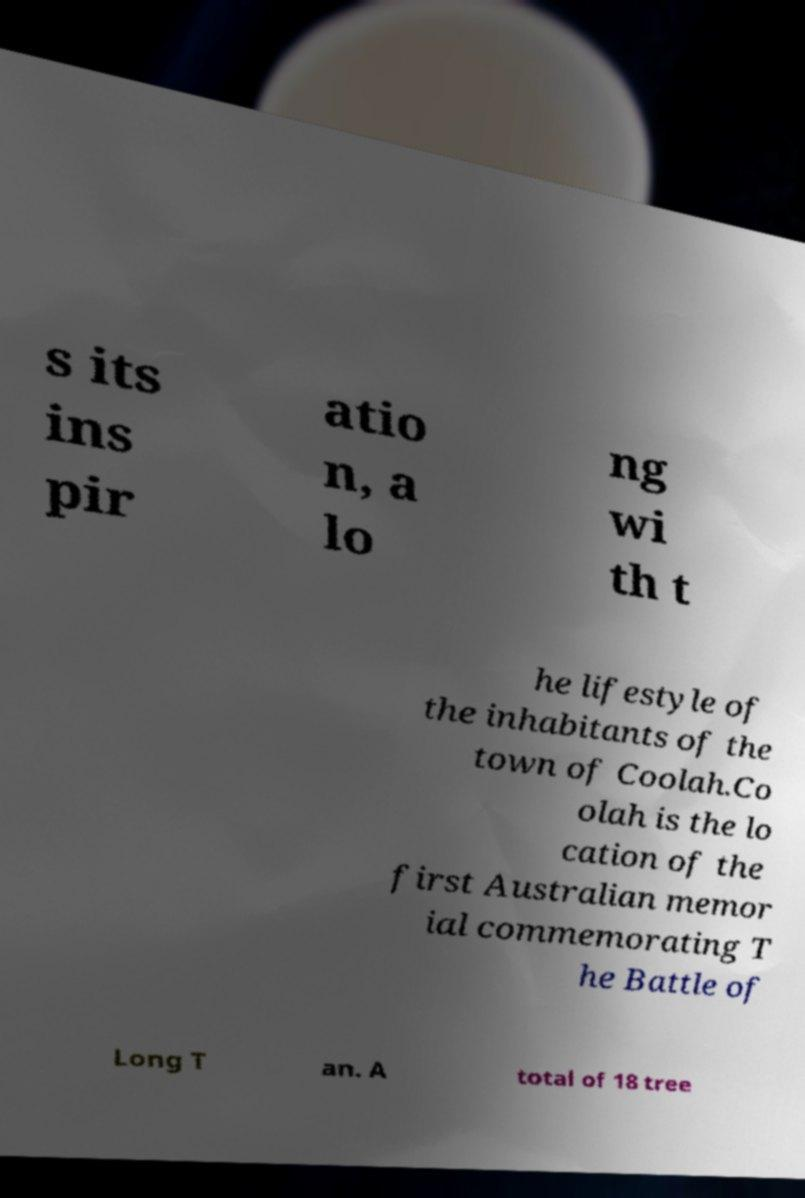What messages or text are displayed in this image? I need them in a readable, typed format. s its ins pir atio n, a lo ng wi th t he lifestyle of the inhabitants of the town of Coolah.Co olah is the lo cation of the first Australian memor ial commemorating T he Battle of Long T an. A total of 18 tree 